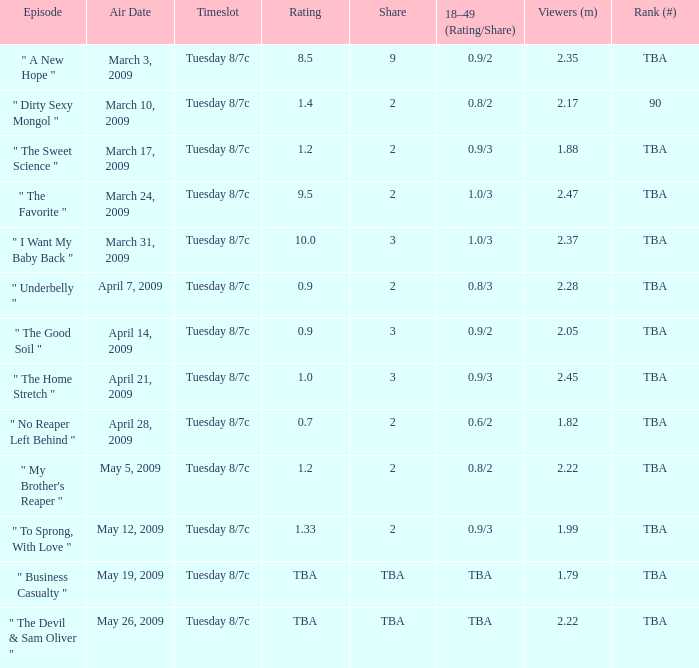What is the airing time for the episode that was on april 28, 2009? Tuesday 8/7c. 